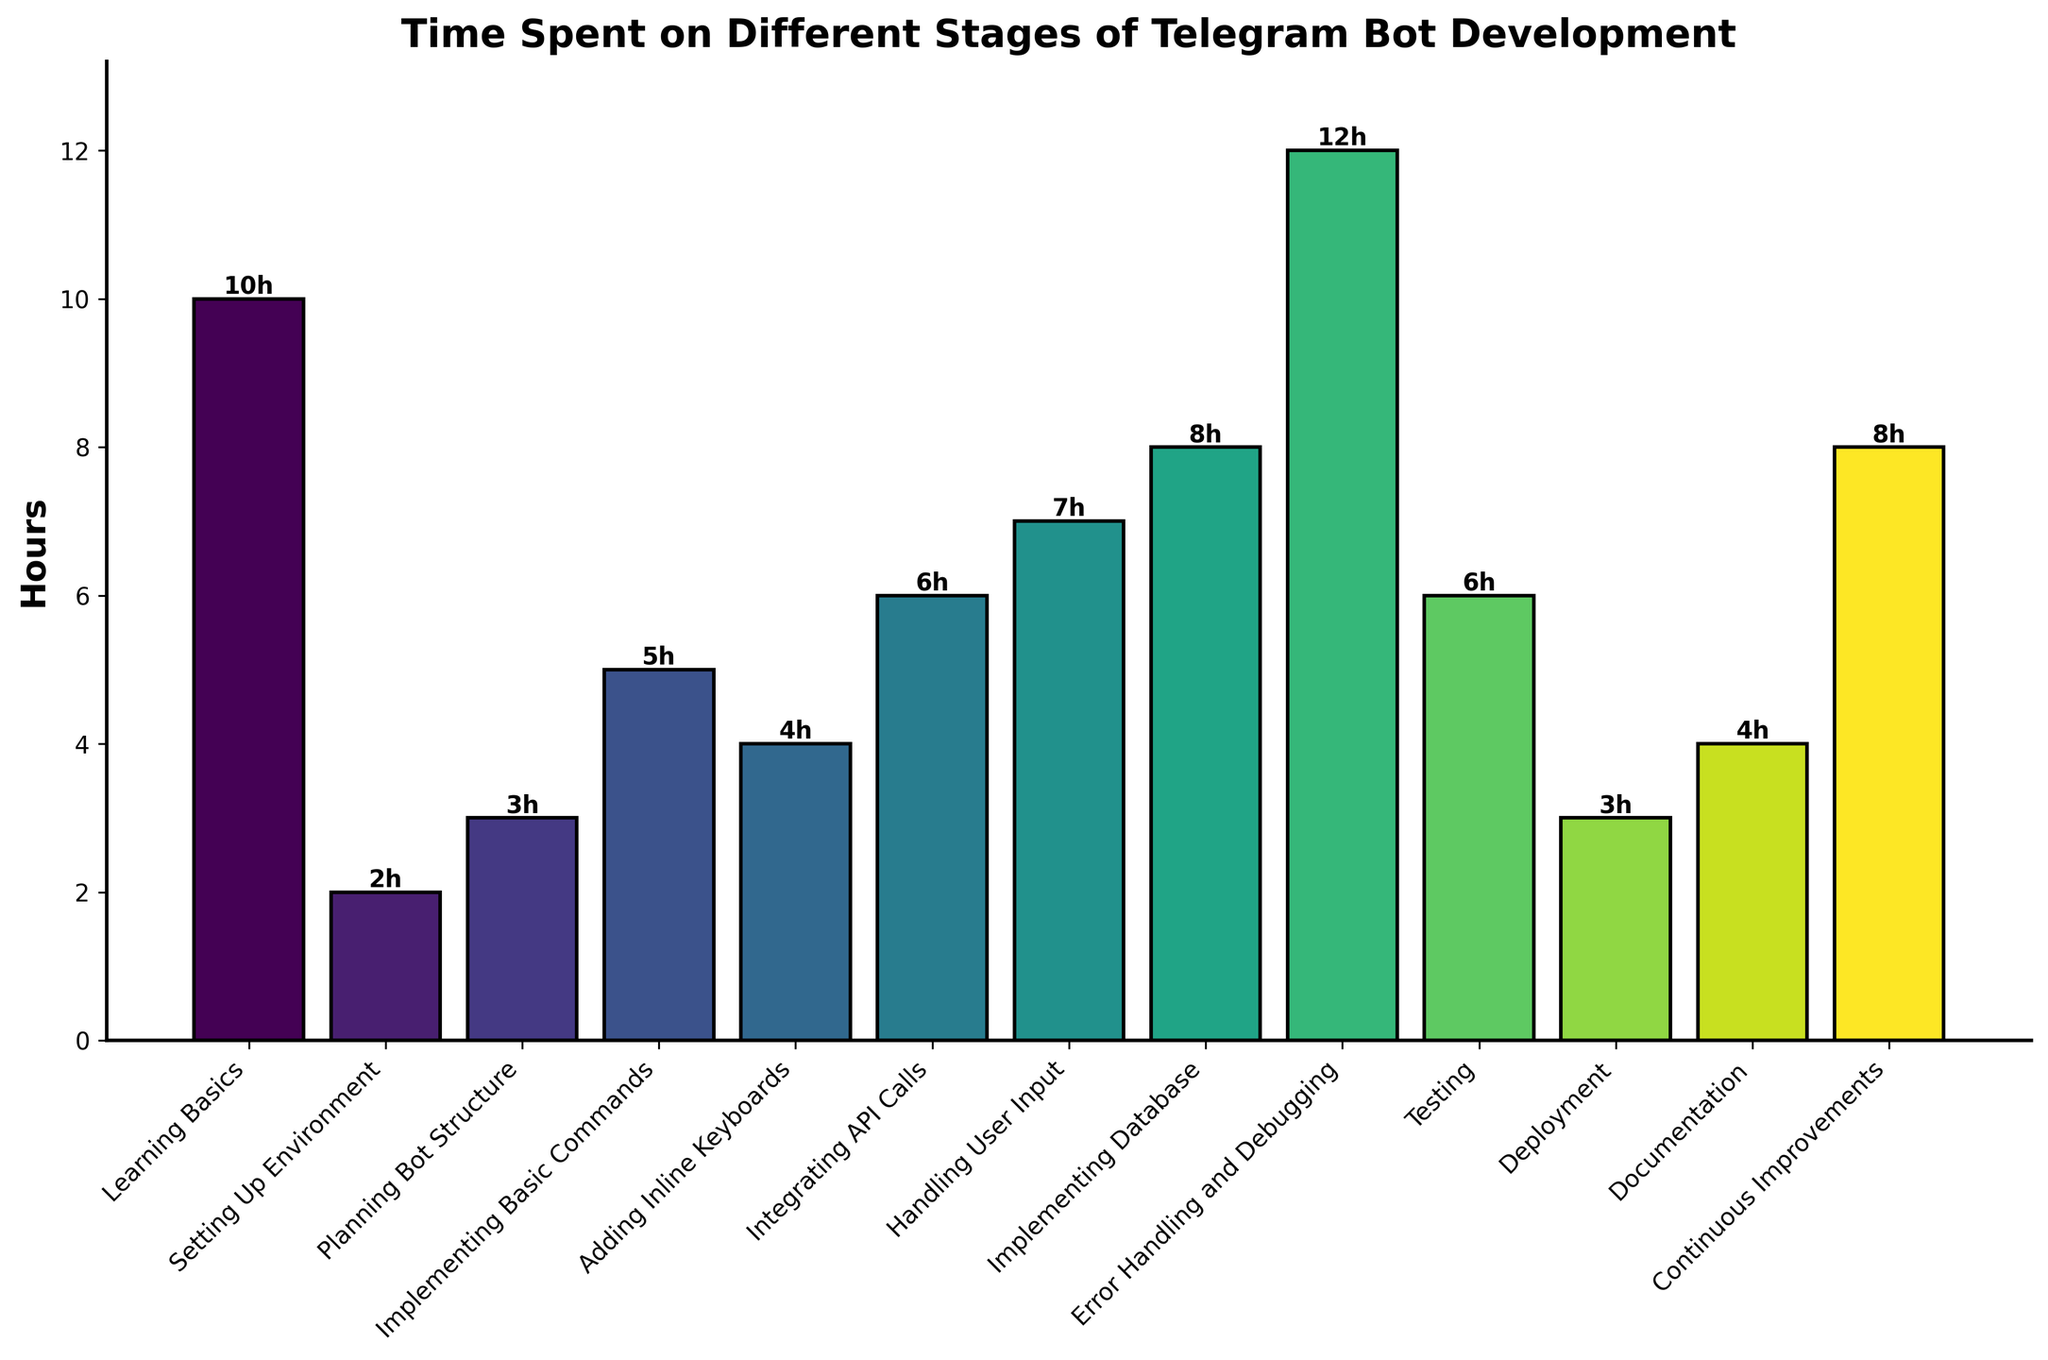What is the stage with the highest number of hours spent? The bar with the greatest height represents the stage with the highest number of hours. This stage is "Error Handling and Debugging" at 12 hours.
Answer: Error Handling and Debugging What is the total time spent on all stages combined? Add up the heights of all the bars to find the sum of hours. The total is 78 hours.
Answer: 78 hours Which stage took more hours, "Implementing Database" or "Error Handling and Debugging"? Compare the heights of the bars for "Implementing Database" and "Error Handling and Debugging". The height of "Error Handling and Debugging" (12 hours) is greater than "Implementing Database" (8 hours).
Answer: Error Handling and Debugging How many stages required exactly 6 hours? Count the number of bars with a height of 6. There are two stages, "Integrating API Calls" and "Testing".
Answer: 2 stages What is the average time spent on "Setting Up Environment," "Planning Bot Structure," and "Deployment"? Add the hours for these stages (2, 3, and 3) and divide by the number of stages (3). (2 + 3 + 3) / 3 = 8 / 3 ≈ 2.67 hours.
Answer: 2.67 hours What is the difference in hours between "Learning Basics" and "Continuous Improvements"? Subtract the hours spent on "Continuous Improvements" from "Learning Basics". 10 - 8 = 2 hours.
Answer: 2 hours How many stages required more than 5 hours? Count the number of bars with a height greater than 5. There are five such stages: "Handling User Input", "Implementing Database," "Error Handling and Debugging," "Testing," and "Continuous Improvements".
Answer: 5 stages What is the total time spent on "Implementing Basic Commands," "Adding Inline Keyboards," and "Documentation"? Add the hours for these stages (5, 4, and 4). 5 + 4 + 4 = 13 hours.
Answer: 13 hours Which stage has the least amount of time invested? Find the bar with the smallest height. The "Setting Up Environment" stage took the least amount of time with 2 hours.
Answer: Setting Up Environment What is the difference in height (hours) between the stages "Learning Basics" and "Error Handling and Debugging"? Subtract the height of the bar labeled "Learning Basics" from that of "Error Handling and Debugging". 12 - 10 = 2 hours.
Answer: 2 hours 